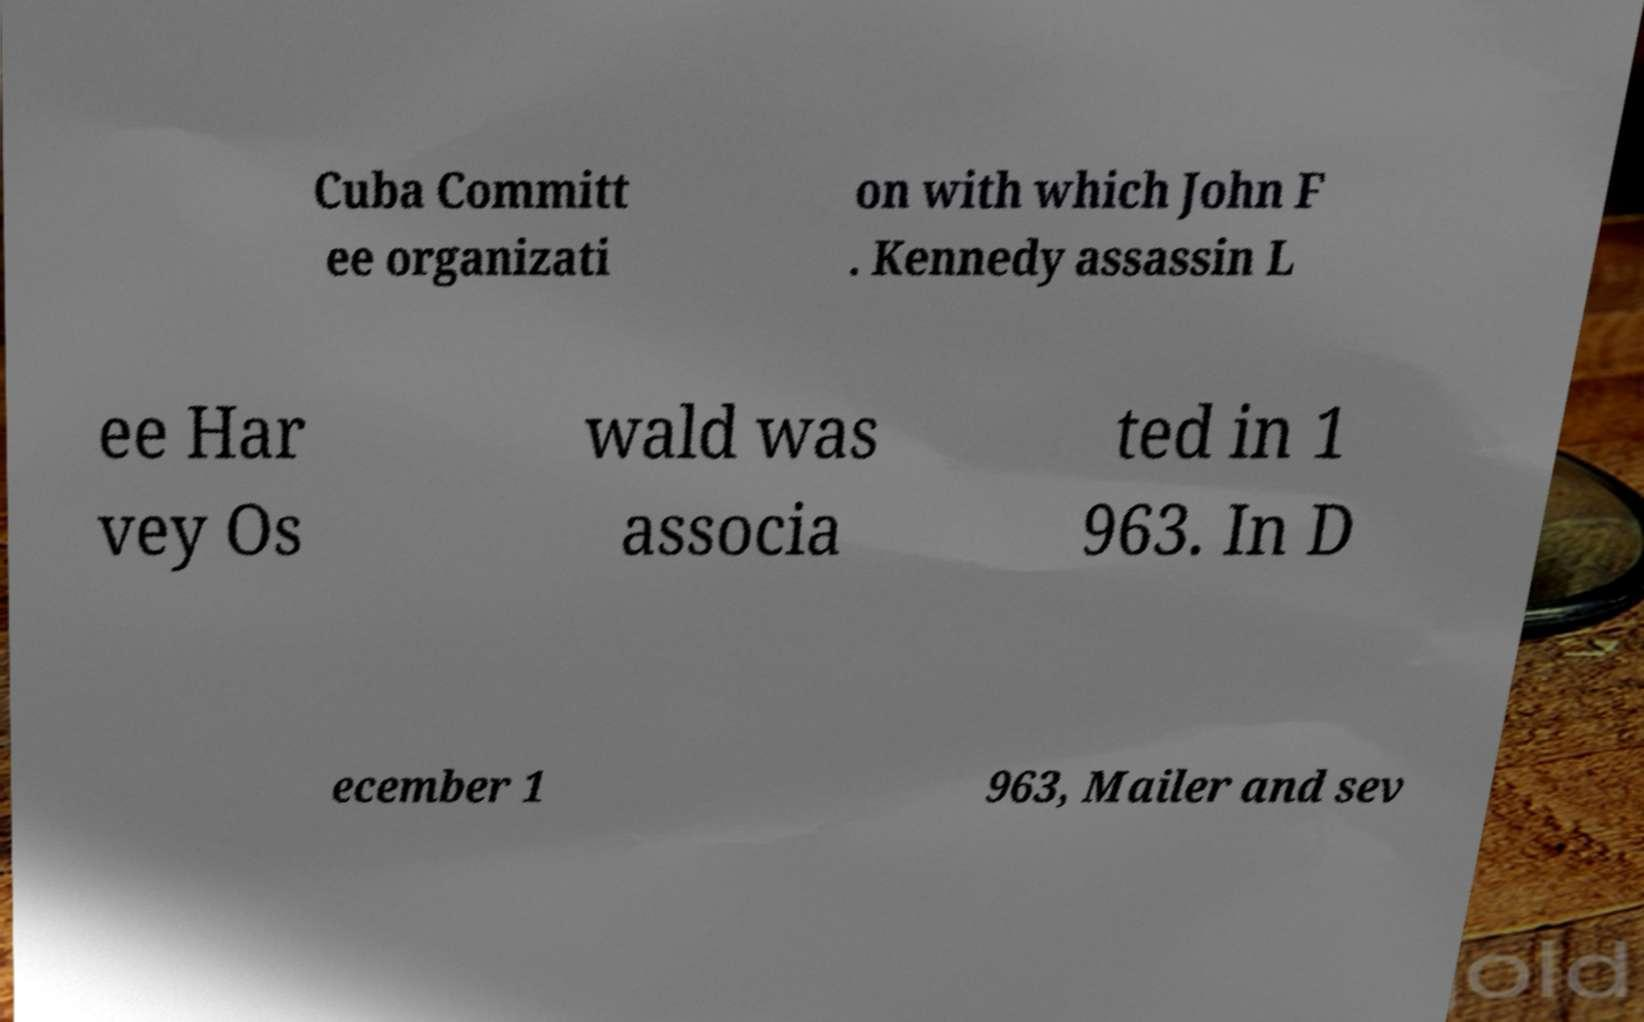Please identify and transcribe the text found in this image. Cuba Committ ee organizati on with which John F . Kennedy assassin L ee Har vey Os wald was associa ted in 1 963. In D ecember 1 963, Mailer and sev 